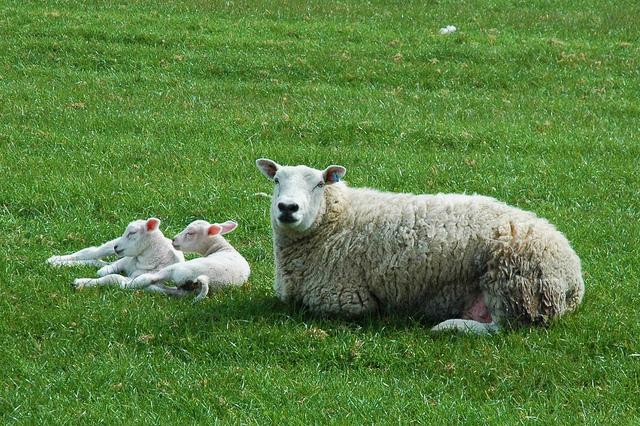How many sheep are seen?
Answer briefly. 3. What animals are these?
Write a very short answer. Sheep. Are the lambs about the same size?
Short answer required. Yes. How many sheep are there?
Quick response, please. 3. 